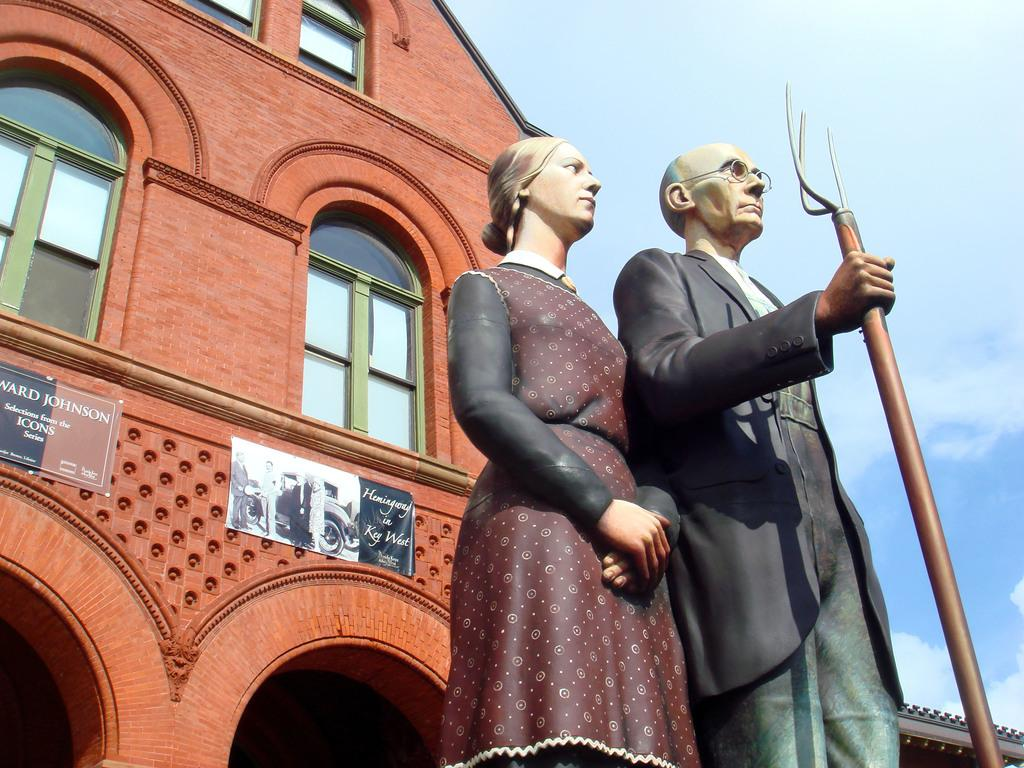What can be seen in the foreground of the image? There are sculptures in the foreground of the image. What is on the building in the image? There are posters on a building. What is visible in the background of the image? The sky is visible in the background of the image. Where is the sink located in the image? There is no sink present in the image. What type of drink is being served in the image? There is no drink being served in the image. 